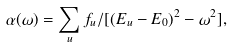<formula> <loc_0><loc_0><loc_500><loc_500>\alpha ( \omega ) = \sum _ { u } f _ { u } / [ ( E _ { u } - E _ { 0 } ) ^ { 2 } - \omega ^ { 2 } ] ,</formula> 